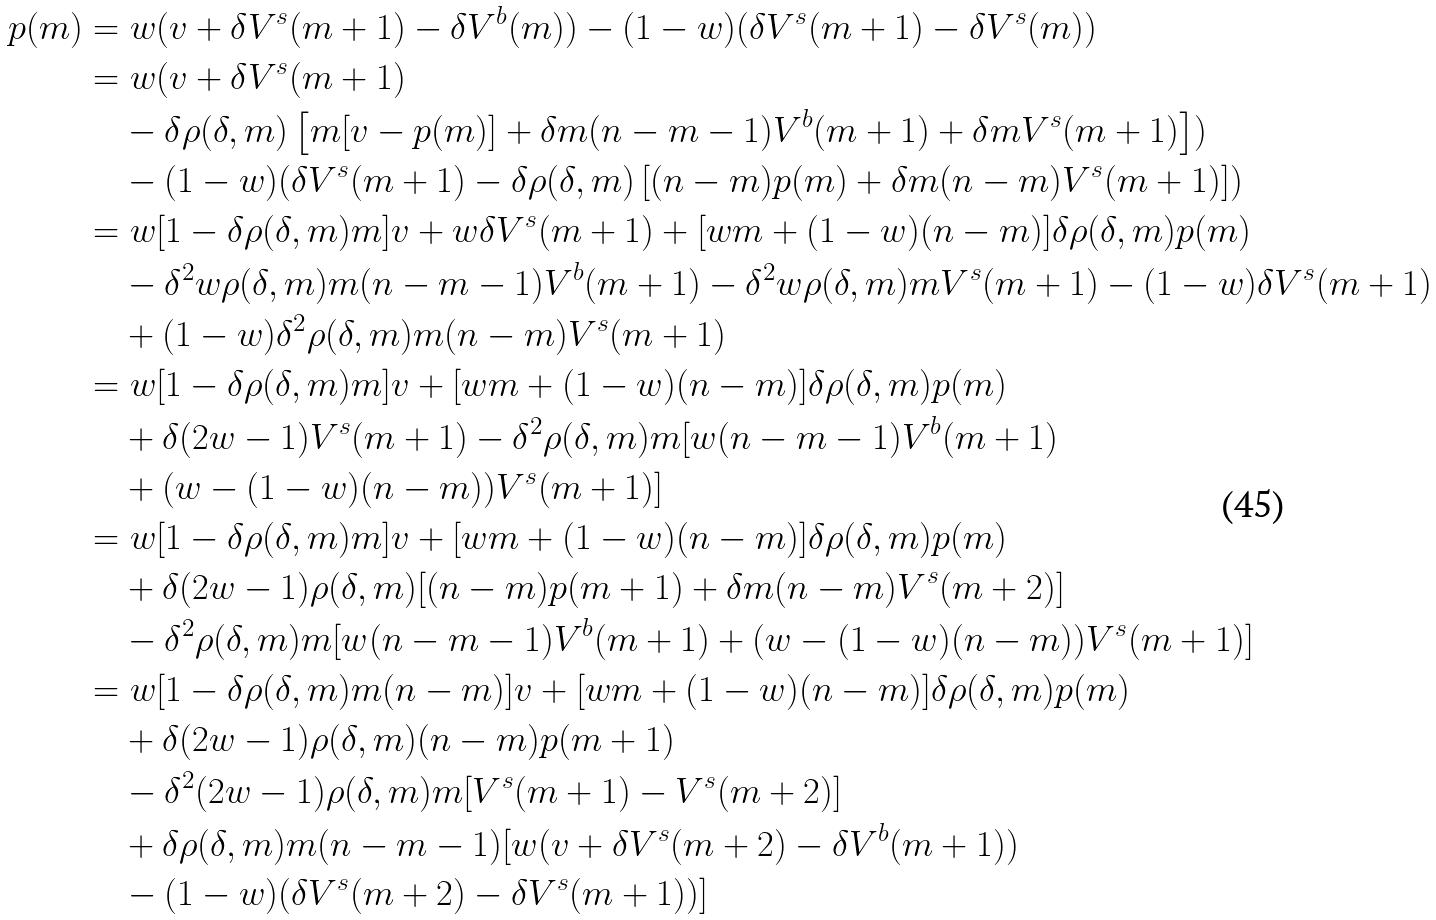Convert formula to latex. <formula><loc_0><loc_0><loc_500><loc_500>p ( m ) & = w ( v + \delta V ^ { s } ( m + 1 ) - \delta V ^ { b } ( m ) ) - ( 1 - w ) ( \delta V ^ { s } ( m + 1 ) - \delta V ^ { s } ( m ) ) \\ & = w ( v + \delta V ^ { s } ( m + 1 ) \\ & \quad - \delta \rho ( \delta , m ) \left [ m [ v - p ( m ) ] + \delta m ( n - m - 1 ) V ^ { b } ( m + 1 ) + \delta m V ^ { s } ( m + 1 ) \right ] ) \\ & \quad - ( 1 - w ) ( \delta V ^ { s } ( m + 1 ) - \delta \rho ( \delta , m ) \left [ ( n - m ) p ( m ) + \delta m ( n - m ) V ^ { s } ( m + 1 ) \right ] ) \\ & = w [ 1 - \delta \rho ( \delta , m ) m ] v + w \delta V ^ { s } ( m + 1 ) + [ w m + ( 1 - w ) ( n - m ) ] \delta \rho ( \delta , m ) p ( m ) \\ & \quad - \delta ^ { 2 } w \rho ( \delta , m ) m ( n - m - 1 ) V ^ { b } ( m + 1 ) - \delta ^ { 2 } w \rho ( \delta , m ) m V ^ { s } ( m + 1 ) - ( 1 - w ) \delta V ^ { s } ( m + 1 ) \\ & \quad + ( 1 - w ) \delta ^ { 2 } \rho ( \delta , m ) m ( n - m ) V ^ { s } ( m + 1 ) \\ & = w [ 1 - \delta \rho ( \delta , m ) m ] v + [ w m + ( 1 - w ) ( n - m ) ] \delta \rho ( \delta , m ) p ( m ) \\ & \quad + \delta ( 2 w - 1 ) V ^ { s } ( m + 1 ) - \delta ^ { 2 } \rho ( \delta , m ) m [ w ( n - m - 1 ) V ^ { b } ( m + 1 ) \\ & \quad + ( w - ( 1 - w ) ( n - m ) ) V ^ { s } ( m + 1 ) ] \\ & = w [ 1 - \delta \rho ( \delta , m ) m ] v + [ w m + ( 1 - w ) ( n - m ) ] \delta \rho ( \delta , m ) p ( m ) \\ & \quad + \delta ( 2 w - 1 ) \rho ( \delta , m ) [ ( n - m ) p ( m + 1 ) + \delta m ( n - m ) V ^ { s } ( m + 2 ) ] \\ & \quad - \delta ^ { 2 } \rho ( \delta , m ) m [ w ( n - m - 1 ) V ^ { b } ( m + 1 ) + ( w - ( 1 - w ) ( n - m ) ) V ^ { s } ( m + 1 ) ] \\ & = w [ 1 - \delta \rho ( \delta , m ) m ( n - m ) ] v + [ w m + ( 1 - w ) ( n - m ) ] \delta \rho ( \delta , m ) p ( m ) \\ & \quad + \delta ( 2 w - 1 ) \rho ( \delta , m ) ( n - m ) p ( m + 1 ) \\ & \quad - \delta ^ { 2 } ( 2 w - 1 ) \rho ( \delta , m ) m [ V ^ { s } ( m + 1 ) - V ^ { s } ( m + 2 ) ] \\ & \quad + \delta \rho ( \delta , m ) m ( n - m - 1 ) [ w ( v + \delta V ^ { s } ( m + 2 ) - \delta V ^ { b } ( m + 1 ) ) \\ & \quad - ( 1 - w ) ( \delta V ^ { s } ( m + 2 ) - \delta V ^ { s } ( m + 1 ) ) ]</formula> 